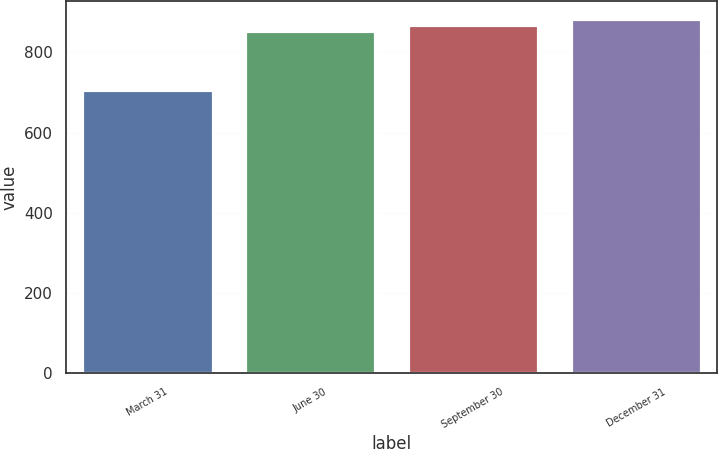Convert chart. <chart><loc_0><loc_0><loc_500><loc_500><bar_chart><fcel>March 31<fcel>June 30<fcel>September 30<fcel>December 31<nl><fcel>705<fcel>853<fcel>867.9<fcel>882.8<nl></chart> 